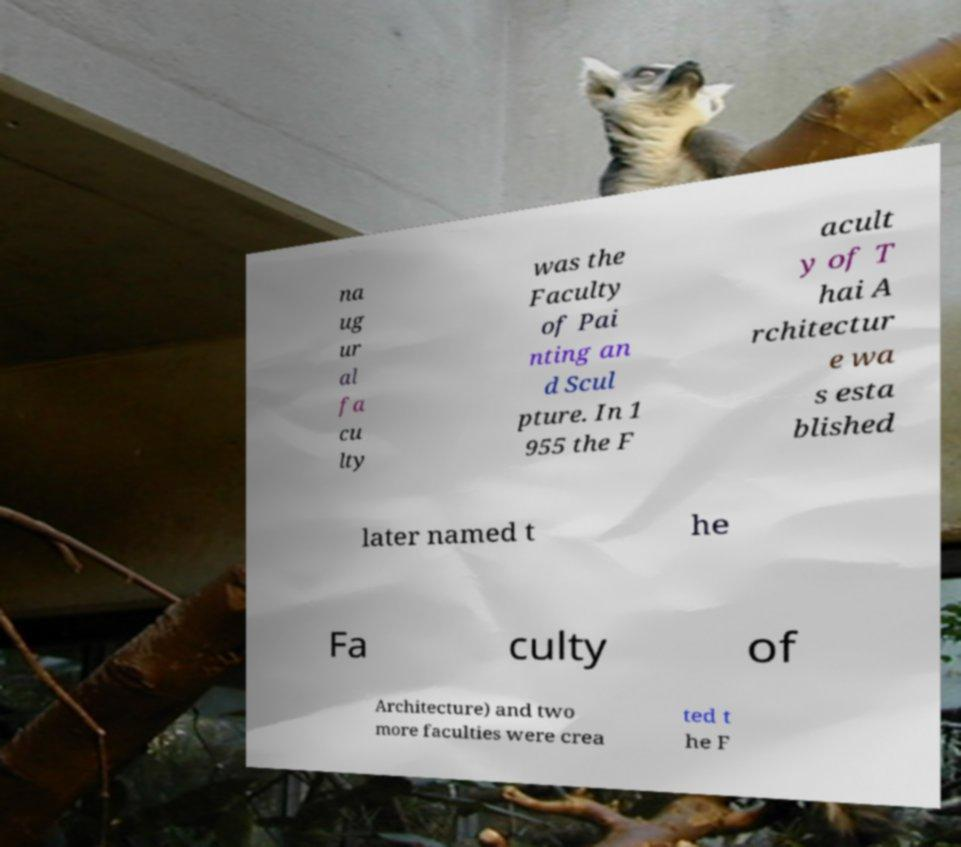Can you accurately transcribe the text from the provided image for me? na ug ur al fa cu lty was the Faculty of Pai nting an d Scul pture. In 1 955 the F acult y of T hai A rchitectur e wa s esta blished later named t he Fa culty of Architecture) and two more faculties were crea ted t he F 